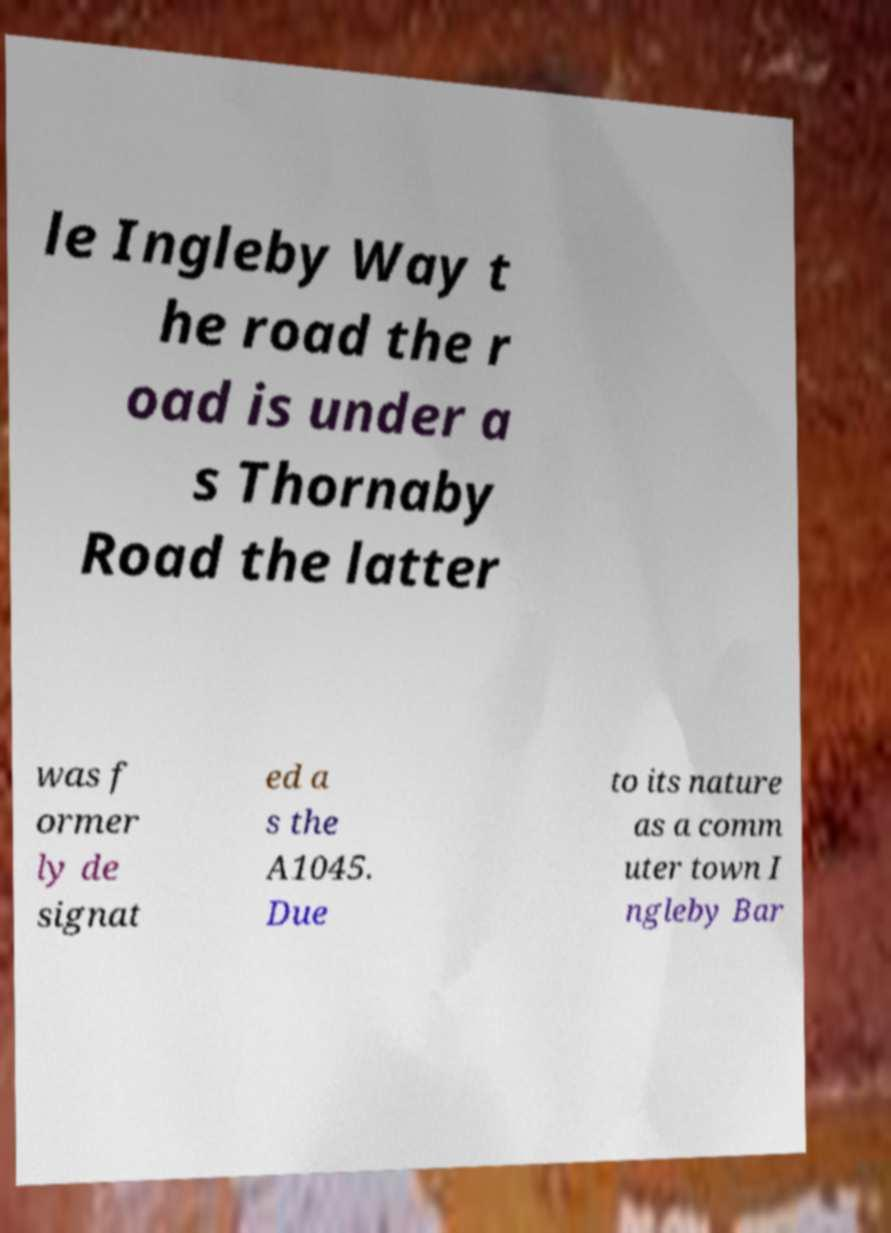Can you accurately transcribe the text from the provided image for me? le Ingleby Way t he road the r oad is under a s Thornaby Road the latter was f ormer ly de signat ed a s the A1045. Due to its nature as a comm uter town I ngleby Bar 